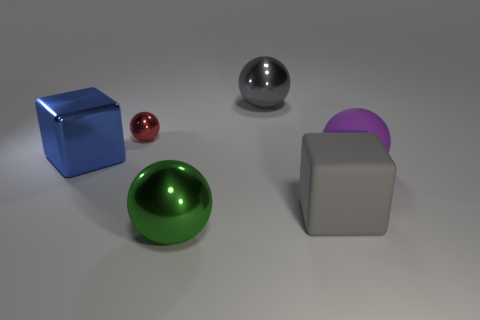Add 4 small red metallic objects. How many objects exist? 10 Subtract all spheres. How many objects are left? 2 Add 2 large green metal things. How many large green metal things are left? 3 Add 6 purple matte balls. How many purple matte balls exist? 7 Subtract 0 green cylinders. How many objects are left? 6 Subtract all large shiny cubes. Subtract all large blue shiny things. How many objects are left? 4 